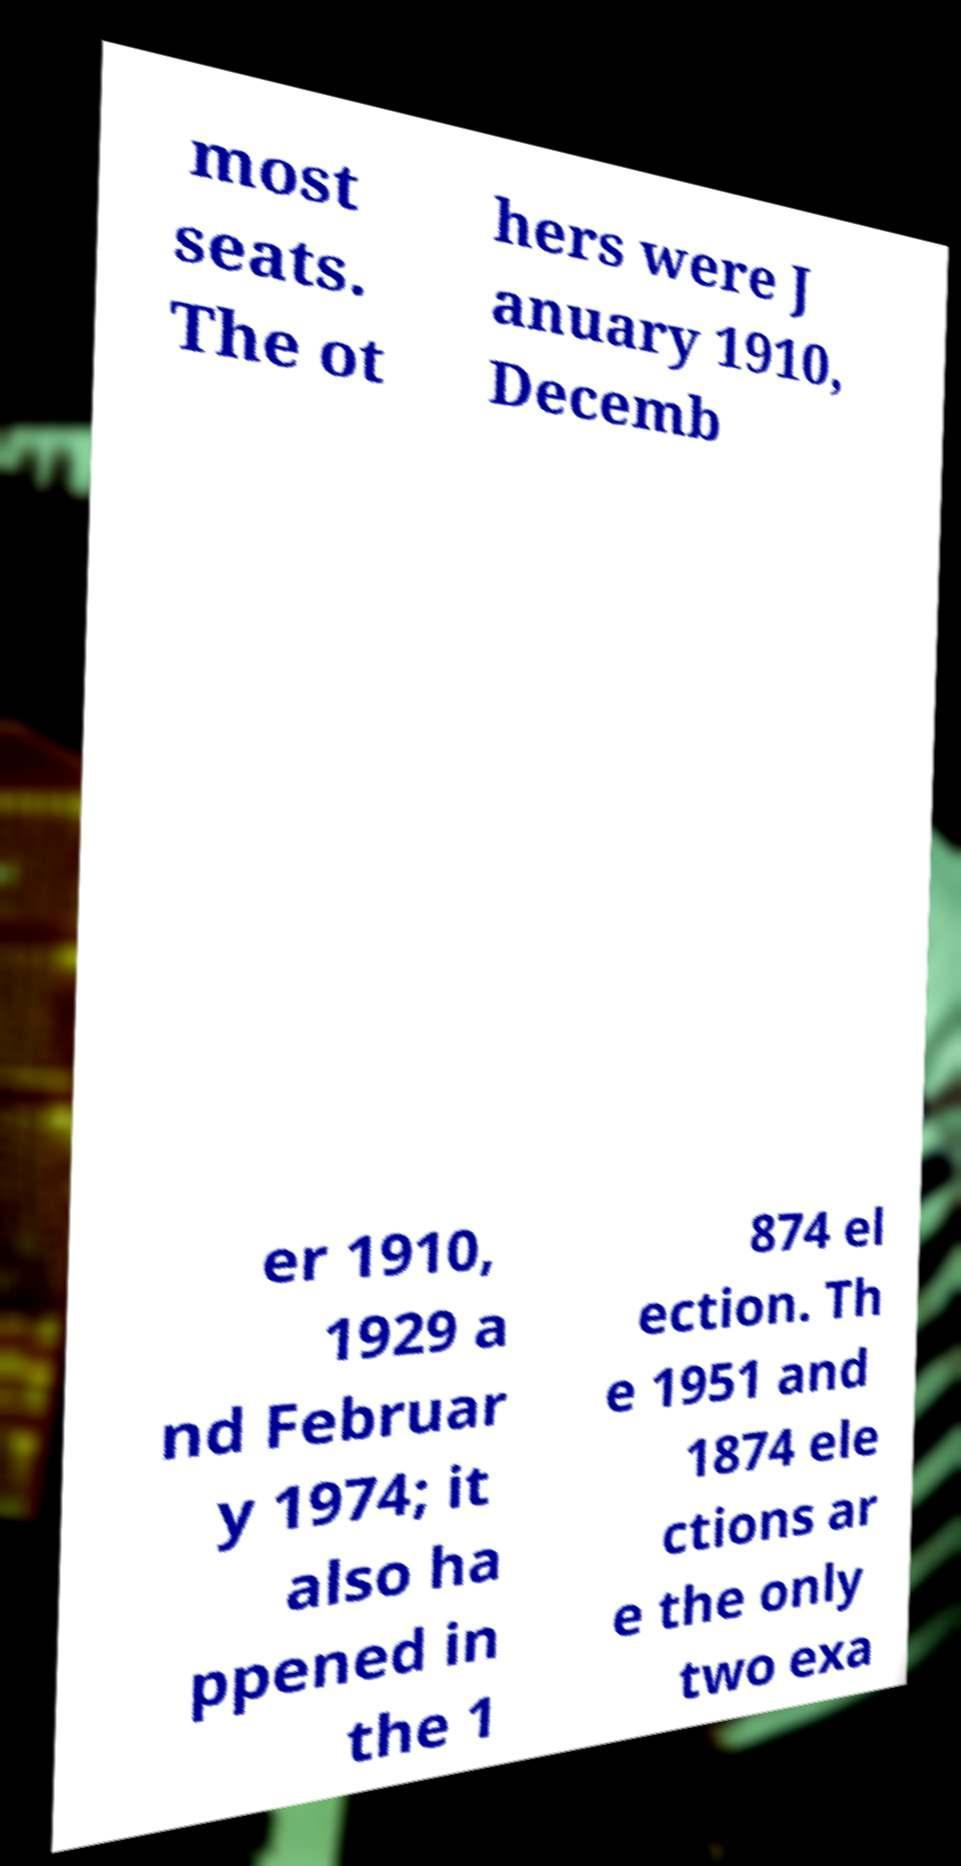There's text embedded in this image that I need extracted. Can you transcribe it verbatim? most seats. The ot hers were J anuary 1910, Decemb er 1910, 1929 a nd Februar y 1974; it also ha ppened in the 1 874 el ection. Th e 1951 and 1874 ele ctions ar e the only two exa 